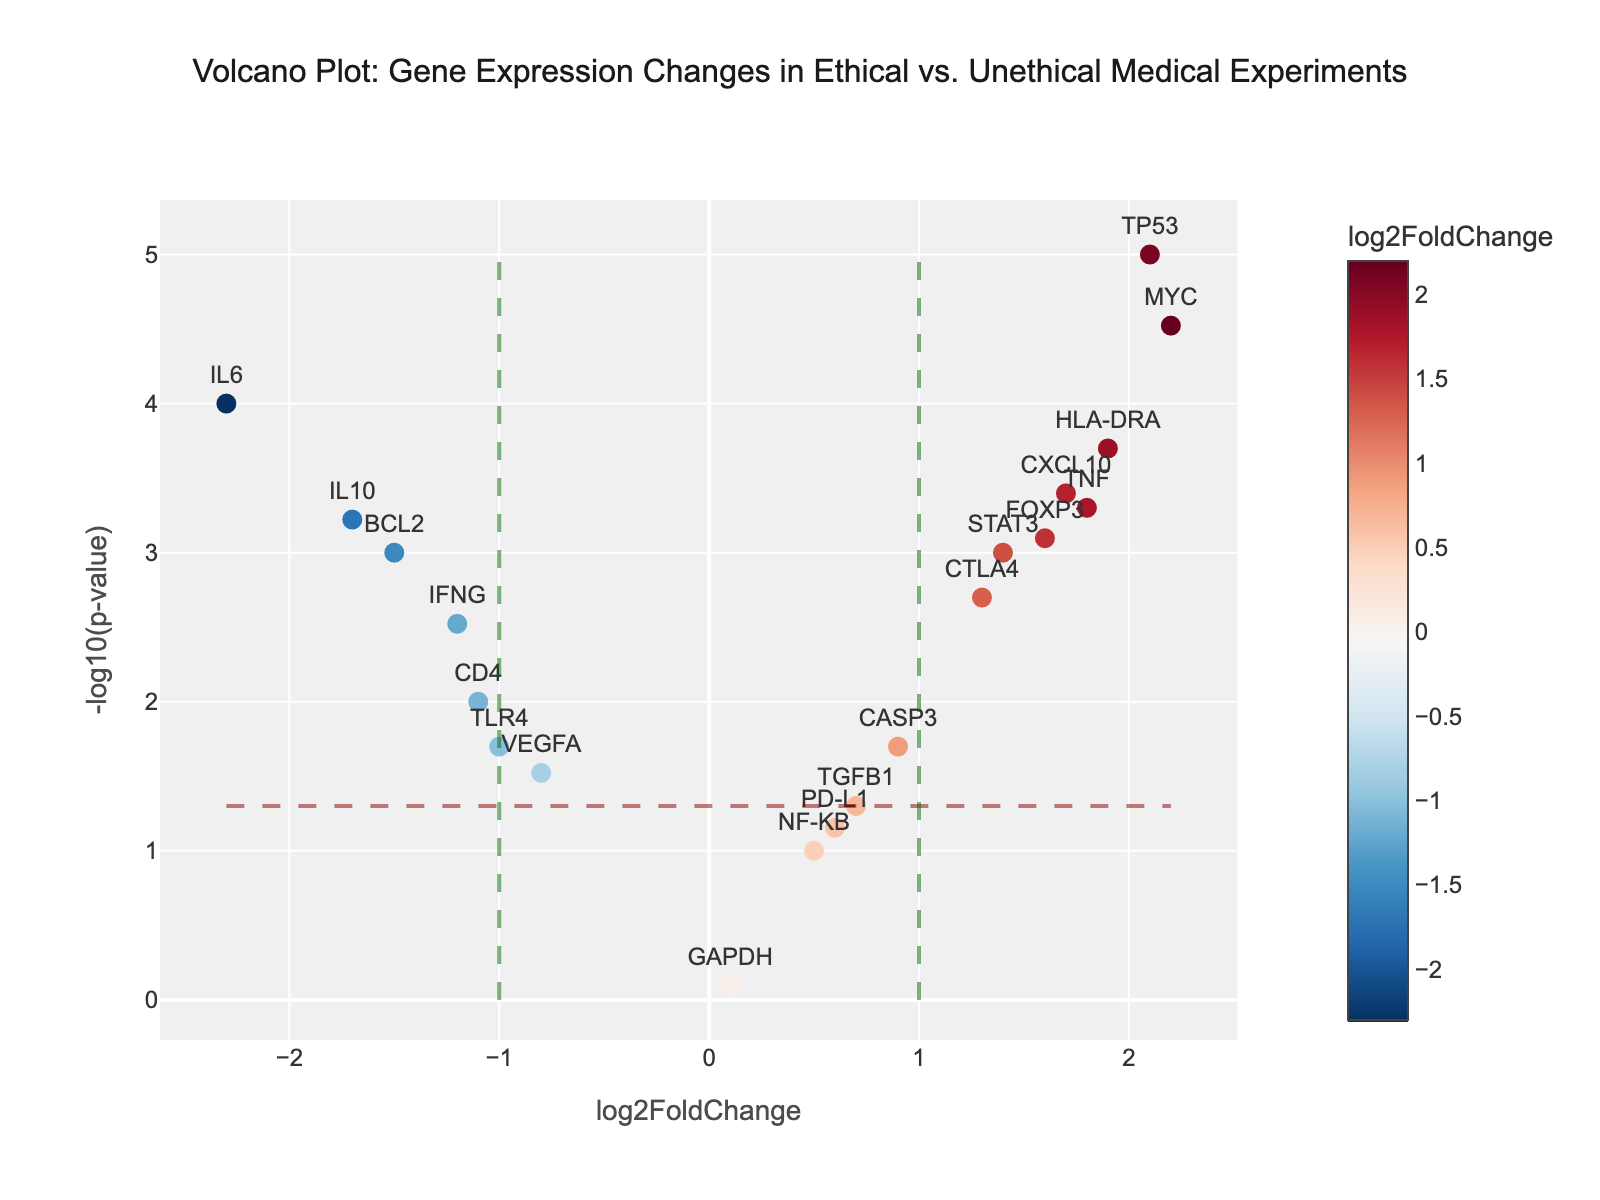How many genes are plotted in the figure? The figure has one marker for each gene listed in the provided data. Counting the markers corresponds to counting the rows in the data table.
Answer: 20 What is the vertical axis label? The label on the vertical axis of the plot represents the transformation applied to the p-values of the data points.
Answer: -log10(p-value) What is the fold change threshold indicated by the vertical dashed lines? The plot features two vertical dashed lines representing the threshold for significant fold changes. These lines are positioned at log2FoldChange values of -1 and 1.
Answer: -1 and 1 Which gene has the smallest p-value? To find the gene with the smallest p-value, we look at the data and identify TP53, which has the smallest p-value (0.00001). In the plot, this gene will have the highest -log10(p-value).
Answer: TP53 What color represents a log2FoldChange increase? In the provided data and plot, positive log2FoldChange values are typically represented by a specific color in the used color scale, usually transitioning from neutral to warm hues.
Answer: Redder hues Which gene has the largest negative log2FoldChange? By reviewing the data and focusing on the most negative log2FoldChange value, IL6 is identified with a log2FoldChange of -2.3. This can also be verified visually on the plot by finding the furthest point to the left.
Answer: IL6 Is there any gene with a non-significant p-value, and if so, which one has the smallest log2FoldChange? Non-significant p-values exceed 0.05. In the data, GAPDH has a p-value of 0.8 and the smallest log2FoldChange of 0.1.
Answer: GAPDH Which genes lie above the p-value threshold (p-value < 0.05) and have a log2FoldChange greater than 1? To answer, we locate genes captured within the fold change threshold and surpassing the significance threshold. These are TP53, HLA-DRA, FOXP3, CXCL10, MYC, TNF, and STAT3.
Answer: TP53, HLA-DRA, FOXP3, CXCL10, MYC, TNF, STAT3 Does any gene exhibit a log2FoldChange greater than 2? We search the data for log2FoldChange values exceeding 2.0. TP53 and MYC meet this criterion, as seen plotted beyond the log2FoldChange threshold line.
Answer: TP53, MYC 